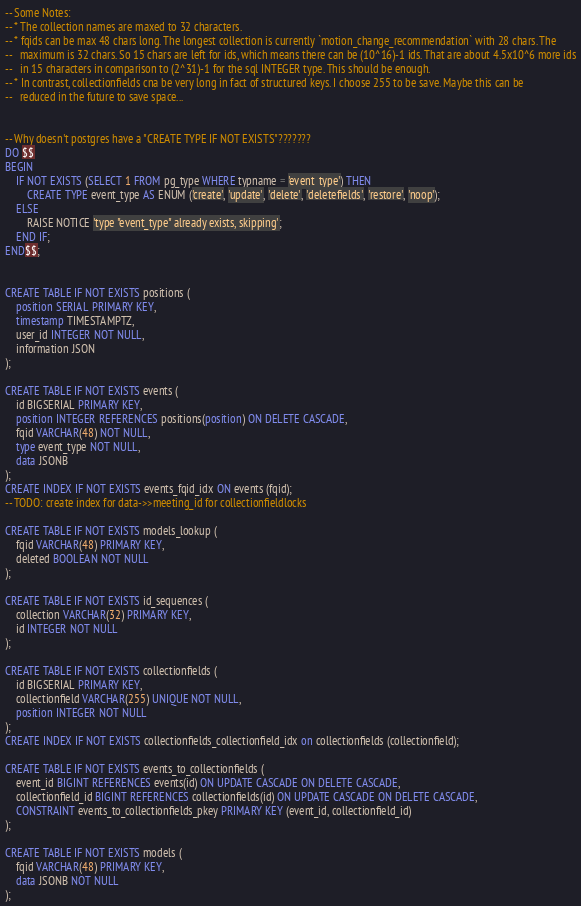<code> <loc_0><loc_0><loc_500><loc_500><_SQL_>-- Some Notes:
-- * The collection names are maxed to 32 characters.
-- * fqids can be max 48 chars long. The longest collection is currently `motion_change_recommendation` with 28 chars. The
--   maximum is 32 chars. So 15 chars are left for ids, which means there can be (10^16)-1 ids. That are about 4.5x10^6 more ids
--   in 15 characters in comparison to (2^31)-1 for the sql INTEGER type. This should be enough.
-- * In contrast, collectionfields cna be very long in fact of structured keys. I choose 255 to be save. Maybe this can be
--   reduced in the future to save space...


-- Why doesn't postgres have a "CREATE TYPE IF NOT EXISTS"???????
DO $$
BEGIN
    IF NOT EXISTS (SELECT 1 FROM pg_type WHERE typname = 'event_type') THEN
        CREATE TYPE event_type AS ENUM ('create', 'update', 'delete', 'deletefields', 'restore', 'noop');
    ELSE
        RAISE NOTICE 'type "event_type" already exists, skipping';
    END IF;
END$$;


CREATE TABLE IF NOT EXISTS positions (
    position SERIAL PRIMARY KEY,
    timestamp TIMESTAMPTZ,
    user_id INTEGER NOT NULL,
    information JSON
);

CREATE TABLE IF NOT EXISTS events (
    id BIGSERIAL PRIMARY KEY,
    position INTEGER REFERENCES positions(position) ON DELETE CASCADE,
    fqid VARCHAR(48) NOT NULL,
    type event_type NOT NULL,
    data JSONB
);
CREATE INDEX IF NOT EXISTS events_fqid_idx ON events (fqid);
-- TODO: create index for data->>meeting_id for collectionfieldlocks

CREATE TABLE IF NOT EXISTS models_lookup (
    fqid VARCHAR(48) PRIMARY KEY,
    deleted BOOLEAN NOT NULL
);

CREATE TABLE IF NOT EXISTS id_sequences (
    collection VARCHAR(32) PRIMARY KEY,
    id INTEGER NOT NULL
);

CREATE TABLE IF NOT EXISTS collectionfields (
    id BIGSERIAL PRIMARY KEY,
    collectionfield VARCHAR(255) UNIQUE NOT NULL,
    position INTEGER NOT NULL
);
CREATE INDEX IF NOT EXISTS collectionfields_collectionfield_idx on collectionfields (collectionfield);

CREATE TABLE IF NOT EXISTS events_to_collectionfields (
    event_id BIGINT REFERENCES events(id) ON UPDATE CASCADE ON DELETE CASCADE,
    collectionfield_id BIGINT REFERENCES collectionfields(id) ON UPDATE CASCADE ON DELETE CASCADE,
    CONSTRAINT events_to_collectionfields_pkey PRIMARY KEY (event_id, collectionfield_id)
);

CREATE TABLE IF NOT EXISTS models (
    fqid VARCHAR(48) PRIMARY KEY,
    data JSONB NOT NULL
);
</code> 